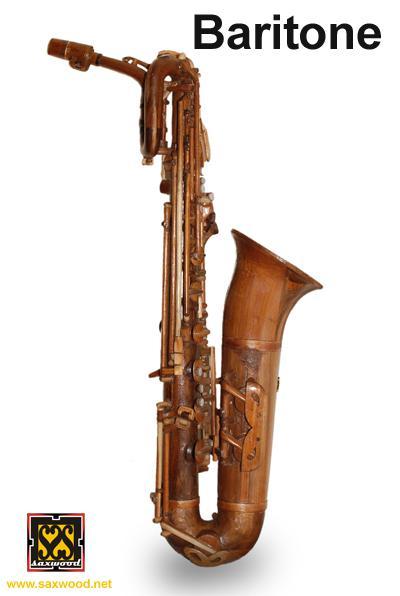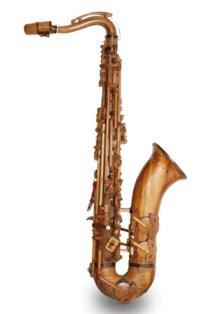The first image is the image on the left, the second image is the image on the right. Evaluate the accuracy of this statement regarding the images: "The saxophones are standing against a white background". Is it true? Answer yes or no. Yes. 